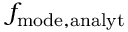<formula> <loc_0><loc_0><loc_500><loc_500>f _ { m o d e , a n a l y t }</formula> 